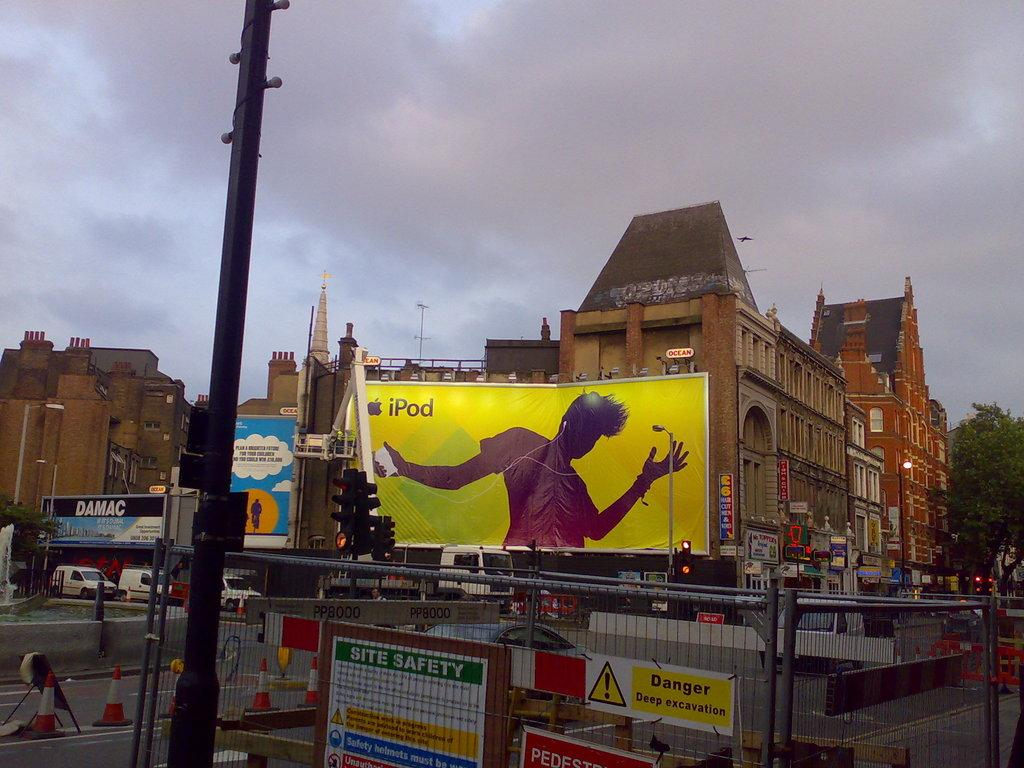Provide a one-sentence caption for the provided image. an ipod advertisement is hanging on a building. 